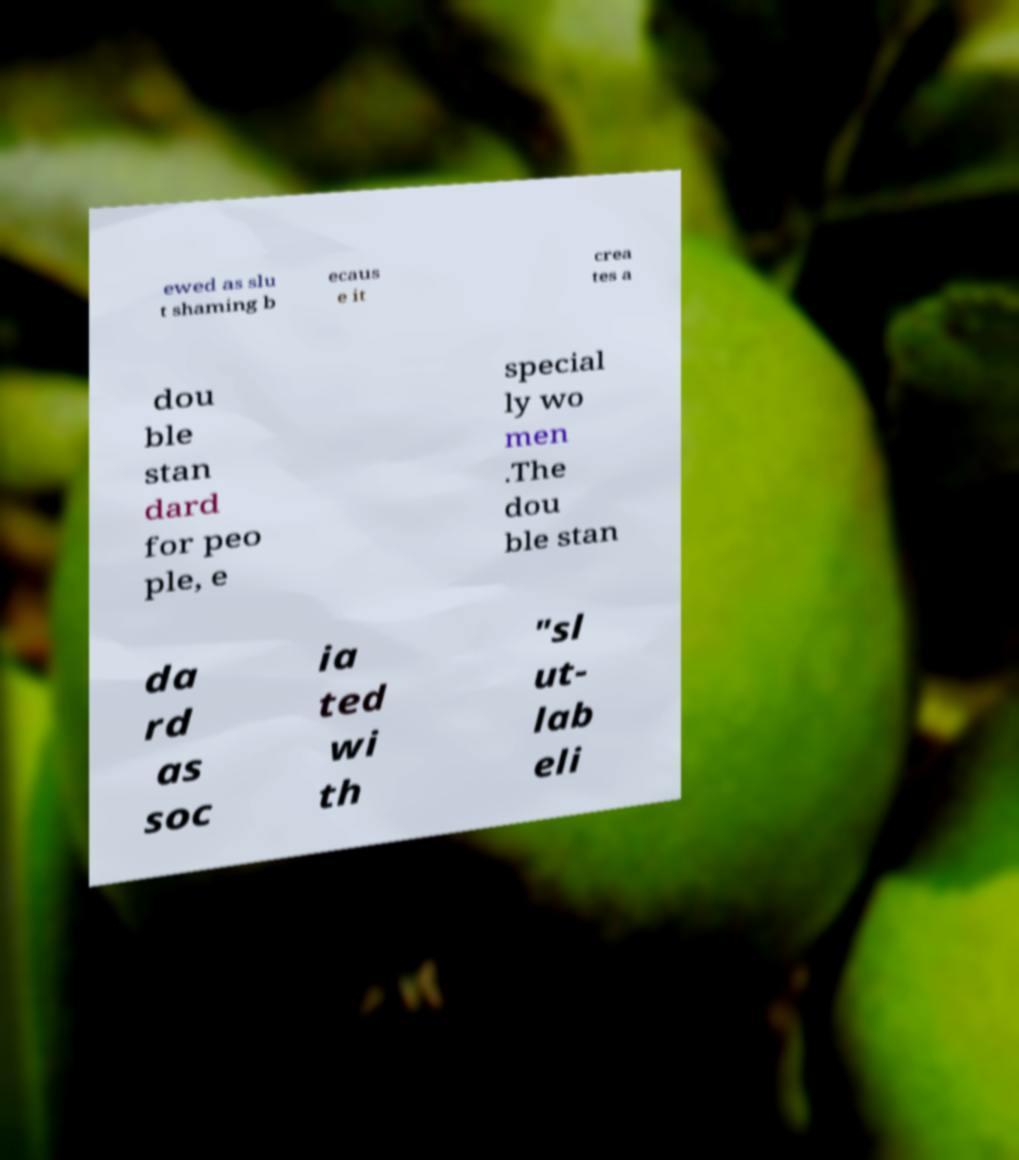For documentation purposes, I need the text within this image transcribed. Could you provide that? ewed as slu t shaming b ecaus e it crea tes a dou ble stan dard for peo ple, e special ly wo men .The dou ble stan da rd as soc ia ted wi th "sl ut- lab eli 